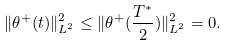<formula> <loc_0><loc_0><loc_500><loc_500>\| \theta ^ { + } ( t ) \| _ { L ^ { 2 } } ^ { 2 } \leq \| \theta ^ { + } ( \frac { T ^ { * } } { 2 } ) \| _ { L ^ { 2 } } ^ { 2 } = 0 .</formula> 